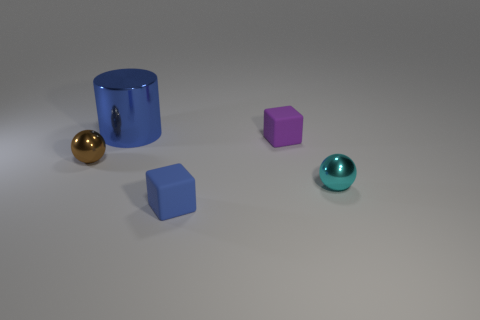There is a cube behind the small brown ball; what number of large shiny cylinders are to the right of it?
Your answer should be very brief. 0. What number of objects are right of the small brown shiny ball and behind the cyan metallic object?
Offer a terse response. 2. What number of objects are either metallic things that are to the right of the cylinder or matte things that are in front of the brown sphere?
Ensure brevity in your answer.  2. What number of other objects are there of the same size as the purple matte block?
Give a very brief answer. 3. There is a blue thing that is behind the small object on the left side of the large metal cylinder; what is its shape?
Your response must be concise. Cylinder. Is the color of the tiny matte cube that is in front of the brown metal object the same as the small sphere on the left side of the purple matte cube?
Provide a short and direct response. No. Is there any other thing that has the same color as the large shiny object?
Your answer should be compact. Yes. The big shiny cylinder is what color?
Make the answer very short. Blue. Are there any small yellow spheres?
Your response must be concise. No. There is a tiny purple object; are there any small matte objects behind it?
Your answer should be compact. No. 